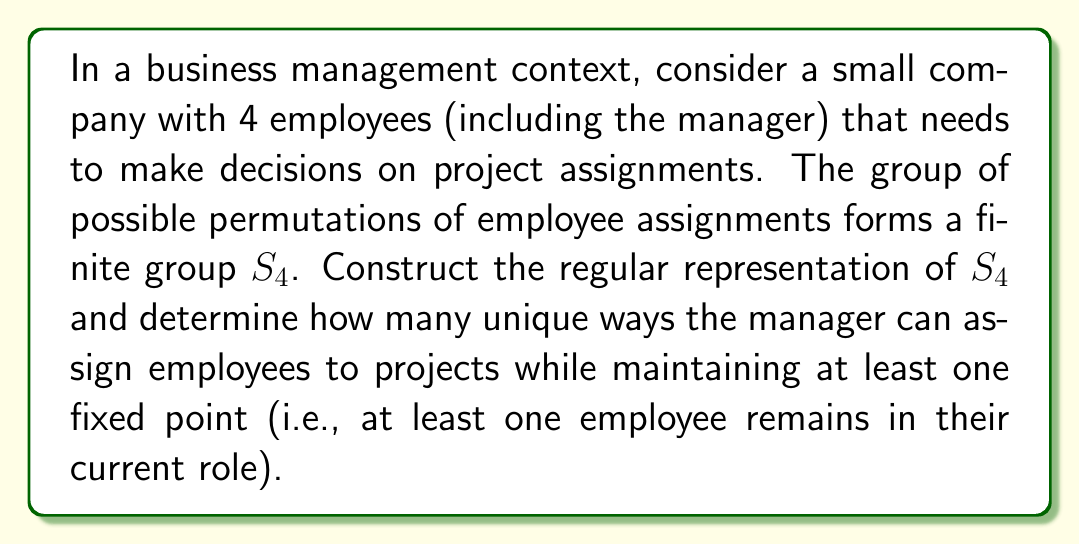Give your solution to this math problem. Let's approach this step-by-step:

1) First, we need to understand the regular representation of $S_4$:
   - $S_4$ has 24 elements (4! permutations).
   - The regular representation assigns each group element to a 24x24 permutation matrix.

2) For each element $g \in S_4$, the regular representation $\rho(g)$ is a 24x24 matrix where:
   $$\rho(g)_{ij} = \begin{cases} 1 & \text{if } g \cdot e_j = e_i \\ 0 & \text{otherwise} \end{cases}$$
   where $e_i$ is the $i$-th standard basis vector.

3) To count permutations with at least one fixed point, we can use the principle of inclusion-exclusion:
   Let $A_i$ be the set of permutations fixing the $i$-th element.

4) We want to calculate $|A_1 \cup A_2 \cup A_3 \cup A_4|$:
   $$|A_1 \cup A_2 \cup A_3 \cup A_4| = \sum_{i=1}^4 |A_i| - \sum_{i<j} |A_i \cap A_j| + \sum_{i<j<k} |A_i \cap A_j \cap A_k| - |A_1 \cap A_2 \cap A_3 \cap A_4|$$

5) Calculate each term:
   - $|A_i| = 3! = 6$ (permutations of the other 3 elements)
   - $|A_i \cap A_j| = 2! = 2$ (permutations of the other 2 elements)
   - $|A_i \cap A_j \cap A_k| = 1! = 1$ (only 1 way to arrange the remaining element)
   - $|A_1 \cap A_2 \cap A_3 \cap A_4| = 1$ (identity permutation)

6) Substituting into the formula:
   $$|A_1 \cup A_2 \cup A_3 \cup A_4| = \binom{4}{1}6 - \binom{4}{2}2 + \binom{4}{3}1 - \binom{4}{4}1 = 24 - 12 + 4 - 1 = 15$$

Therefore, there are 15 ways to assign employees while keeping at least one in their current role.
Answer: 15 unique assignment possibilities 